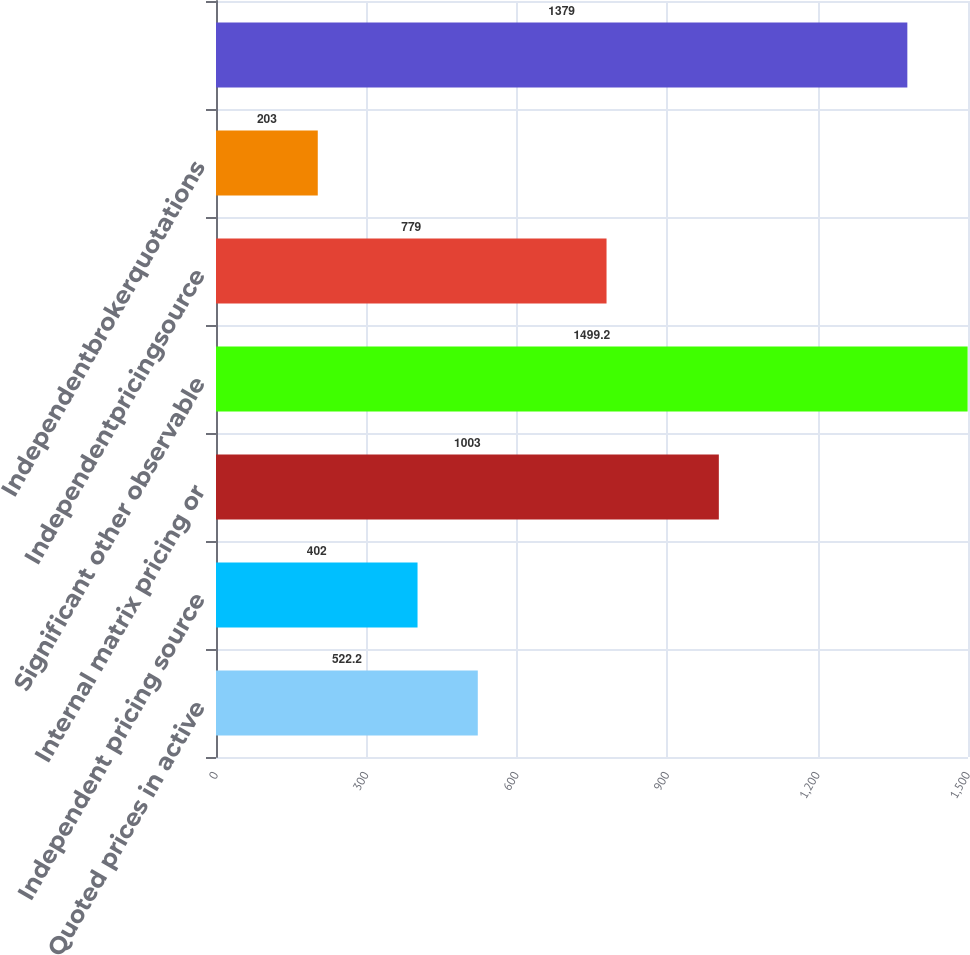Convert chart. <chart><loc_0><loc_0><loc_500><loc_500><bar_chart><fcel>Quoted prices in active<fcel>Independent pricing source<fcel>Internal matrix pricing or<fcel>Significant other observable<fcel>Independentpricingsource<fcel>Independentbrokerquotations<fcel>Unnamed: 6<nl><fcel>522.2<fcel>402<fcel>1003<fcel>1499.2<fcel>779<fcel>203<fcel>1379<nl></chart> 